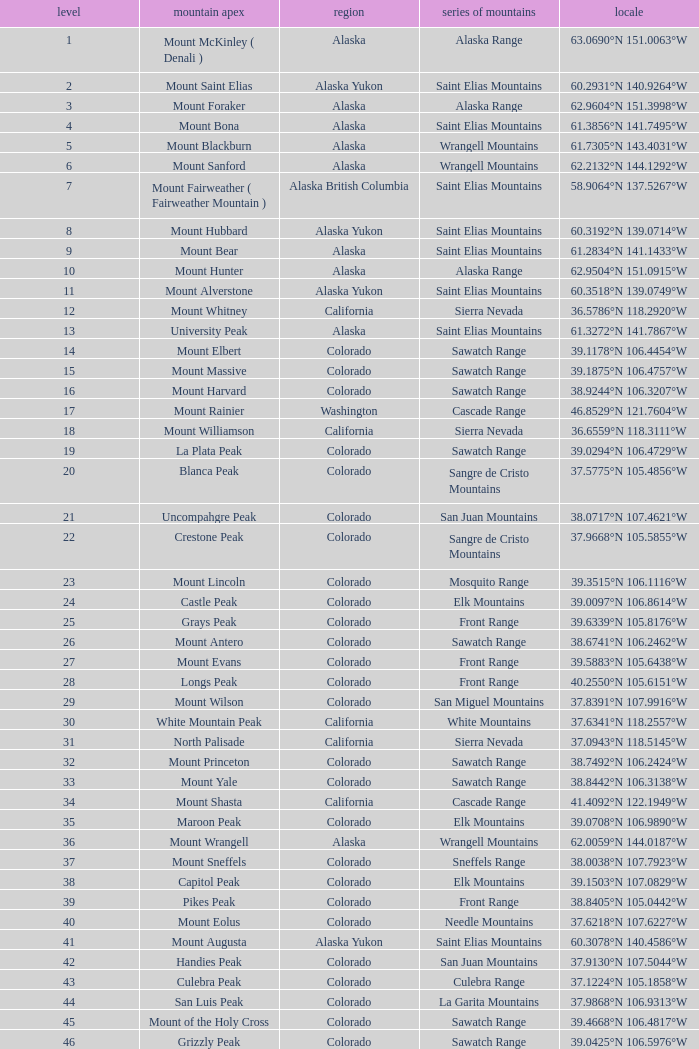What is the mountain range when the state is colorado, rank is higher than 90 and mountain peak is whetstone mountain? West Elk Mountains. 